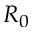Convert formula to latex. <formula><loc_0><loc_0><loc_500><loc_500>R _ { 0 }</formula> 